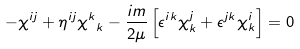Convert formula to latex. <formula><loc_0><loc_0><loc_500><loc_500>- \chi ^ { i j } + \eta ^ { i j } { \chi ^ { k } } _ { k } - \frac { i m } { 2 \mu } \left [ \epsilon ^ { i k } \chi ^ { j } _ { k } + \epsilon ^ { j k } \chi ^ { i } _ { k } \right ] = 0</formula> 